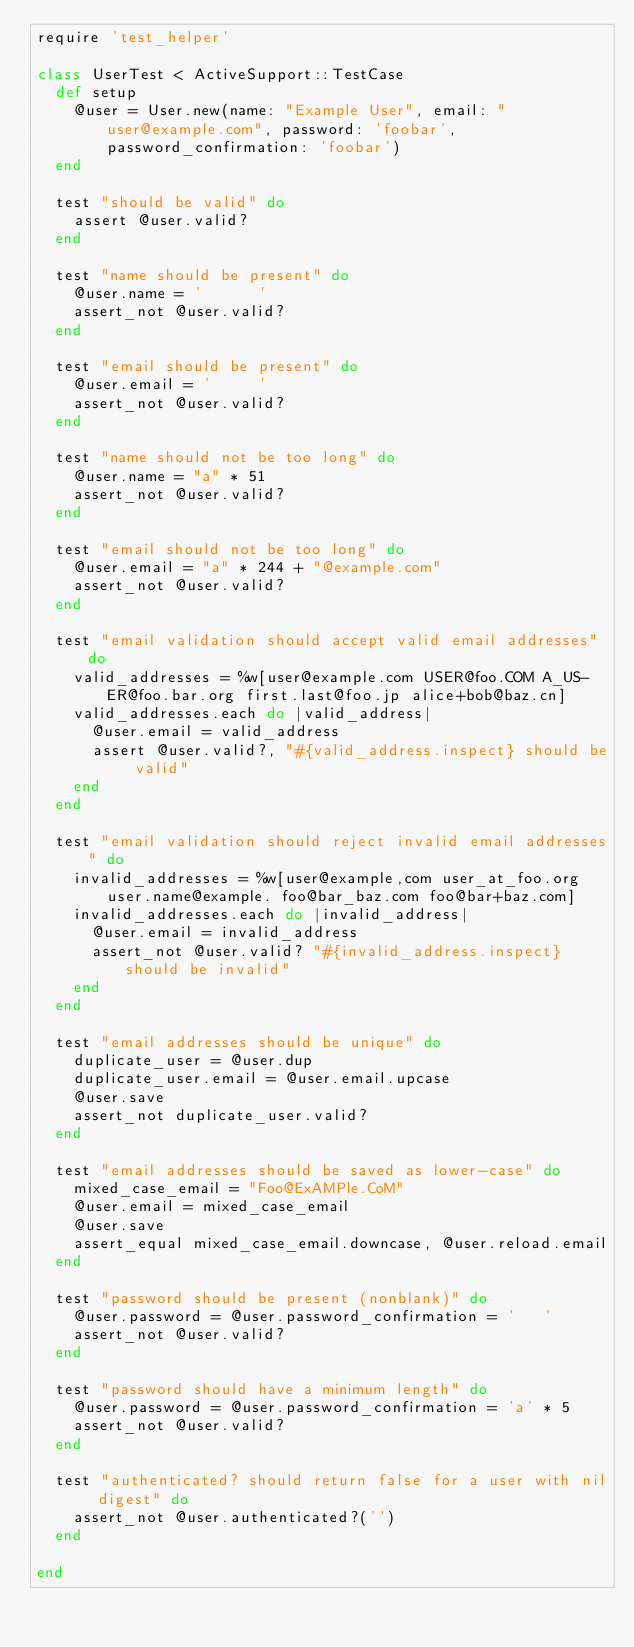Convert code to text. <code><loc_0><loc_0><loc_500><loc_500><_Ruby_>require 'test_helper'

class UserTest < ActiveSupport::TestCase
  def setup
    @user = User.new(name: "Example User", email: "user@example.com", password: 'foobar', password_confirmation: 'foobar')
  end

  test "should be valid" do
    assert @user.valid?
  end

  test "name should be present" do
    @user.name = '      '
    assert_not @user.valid?
  end

  test "email should be present" do
    @user.email = '     '
    assert_not @user.valid?
  end

  test "name should not be too long" do
    @user.name = "a" * 51
    assert_not @user.valid?
  end

  test "email should not be too long" do
    @user.email = "a" * 244 + "@example.com"
    assert_not @user.valid?
  end

  test "email validation should accept valid email addresses" do
    valid_addresses = %w[user@example.com USER@foo.COM A_US-ER@foo.bar.org first.last@foo.jp alice+bob@baz.cn]
    valid_addresses.each do |valid_address|
      @user.email = valid_address
      assert @user.valid?, "#{valid_address.inspect} should be valid"
    end
  end

  test "email validation should reject invalid email addresses" do
    invalid_addresses = %w[user@example,com user_at_foo.org user.name@example. foo@bar_baz.com foo@bar+baz.com]
    invalid_addresses.each do |invalid_address|
      @user.email = invalid_address
      assert_not @user.valid? "#{invalid_address.inspect} should be invalid"
    end
  end

  test "email addresses should be unique" do
    duplicate_user = @user.dup
    duplicate_user.email = @user.email.upcase
    @user.save
    assert_not duplicate_user.valid?
  end

  test "email addresses should be saved as lower-case" do
    mixed_case_email = "Foo@ExAMPle.CoM"
    @user.email = mixed_case_email
    @user.save
    assert_equal mixed_case_email.downcase, @user.reload.email
  end

  test "password should be present (nonblank)" do
    @user.password = @user.password_confirmation = '   '
    assert_not @user.valid?
  end

  test "password should have a minimum length" do
    @user.password = @user.password_confirmation = 'a' * 5
    assert_not @user.valid?
  end

  test "authenticated? should return false for a user with nil digest" do
    assert_not @user.authenticated?('')
  end

end

</code> 